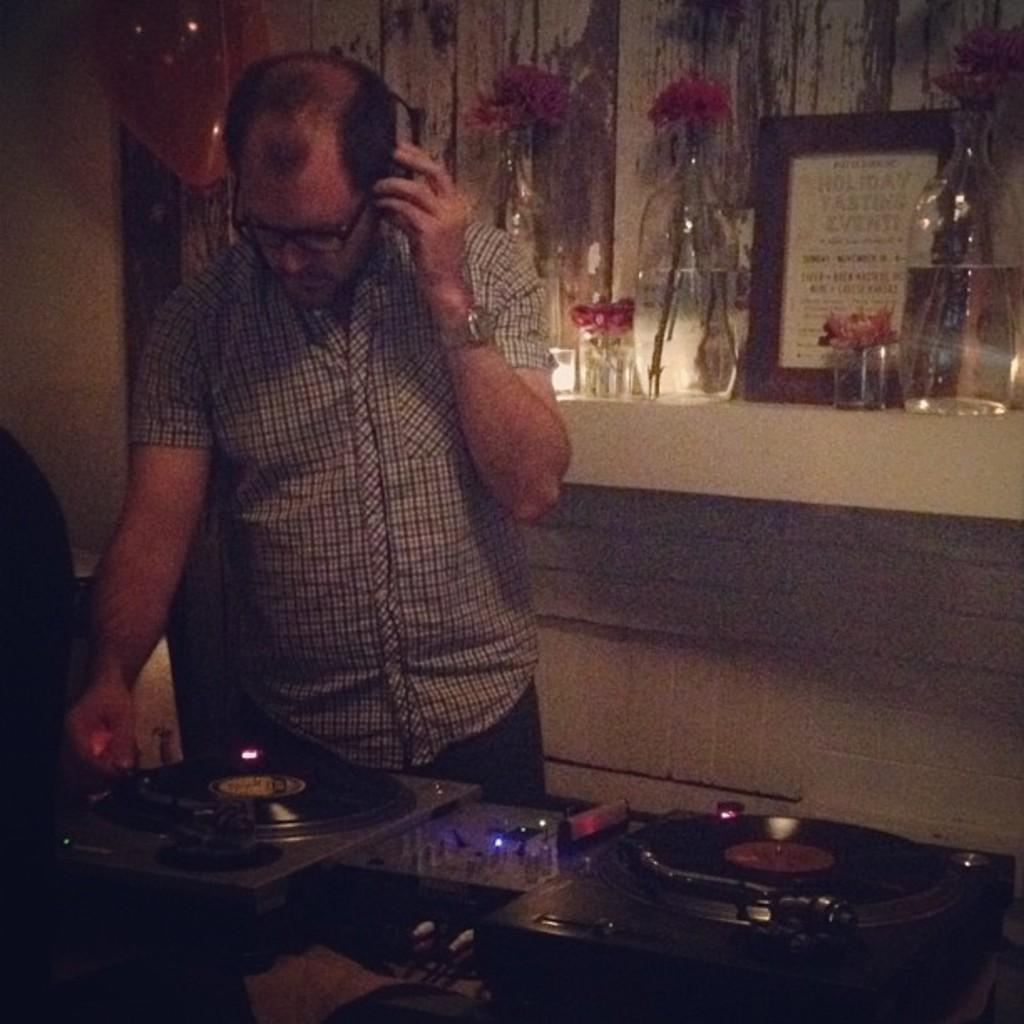Who is the main subject in the image? There is a man in the image. What is the man doing in the image? The man is standing in front of a DJ. What is the man wearing that is related to his activity? The man is wearing headphones. What can be seen on the table in the image? There are frames and flower vases on the table. How many kittens are playing with the DJ's equipment in the image? There are no kittens present in the image, and therefore no such activity can be observed. 